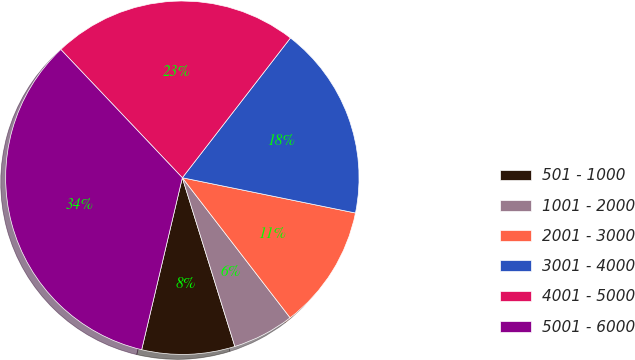Convert chart. <chart><loc_0><loc_0><loc_500><loc_500><pie_chart><fcel>501 - 1000<fcel>1001 - 2000<fcel>2001 - 3000<fcel>3001 - 4000<fcel>4001 - 5000<fcel>5001 - 6000<nl><fcel>8.5%<fcel>5.64%<fcel>11.36%<fcel>17.72%<fcel>22.55%<fcel>34.23%<nl></chart> 